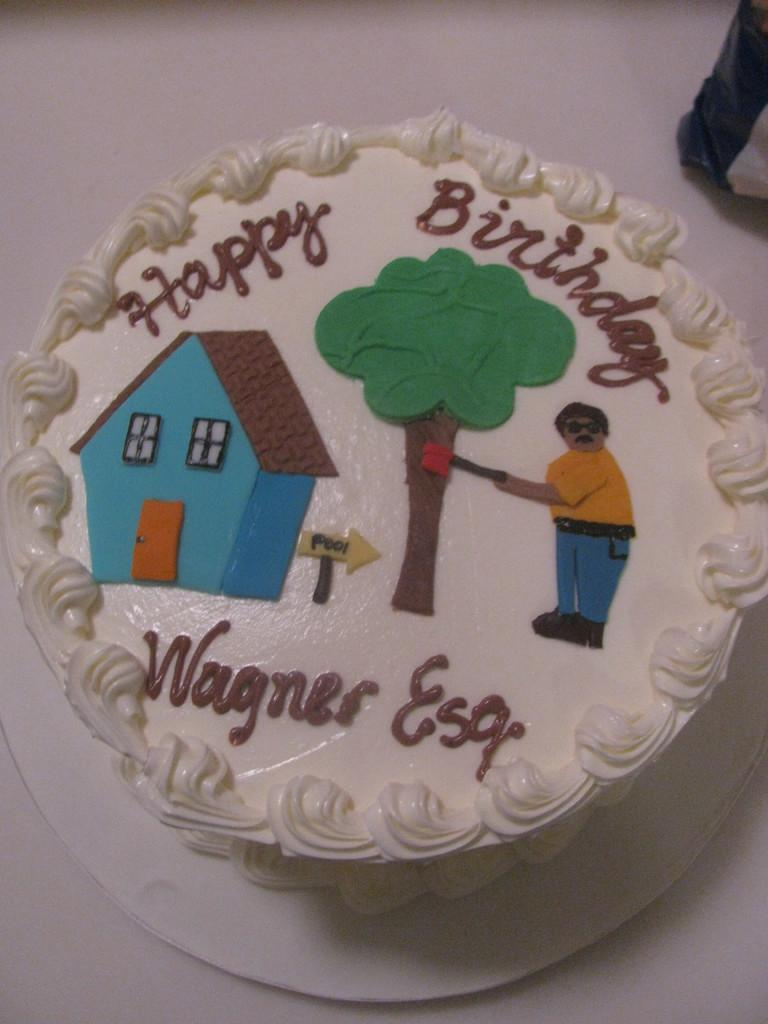What is the main subject in the center of the image? There is a cake in the center of the image. What can be seen on the cake? There is text written on the cake. What is visible in the background of the image? There is a table in the background of the image. What type of stick is used to hold the cake together in the image? There is no stick visible in the image; the cake appears to be a single layer with text written on it. 